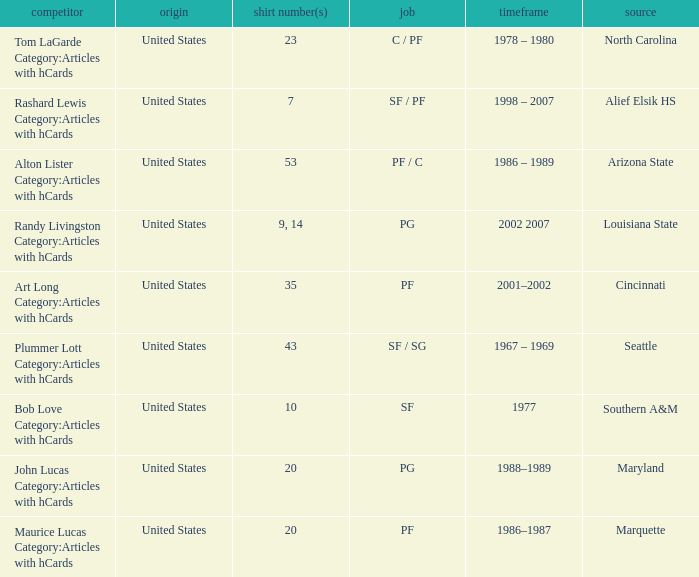Bob Love Category:Articles with hCards is from where? Southern A&M. 